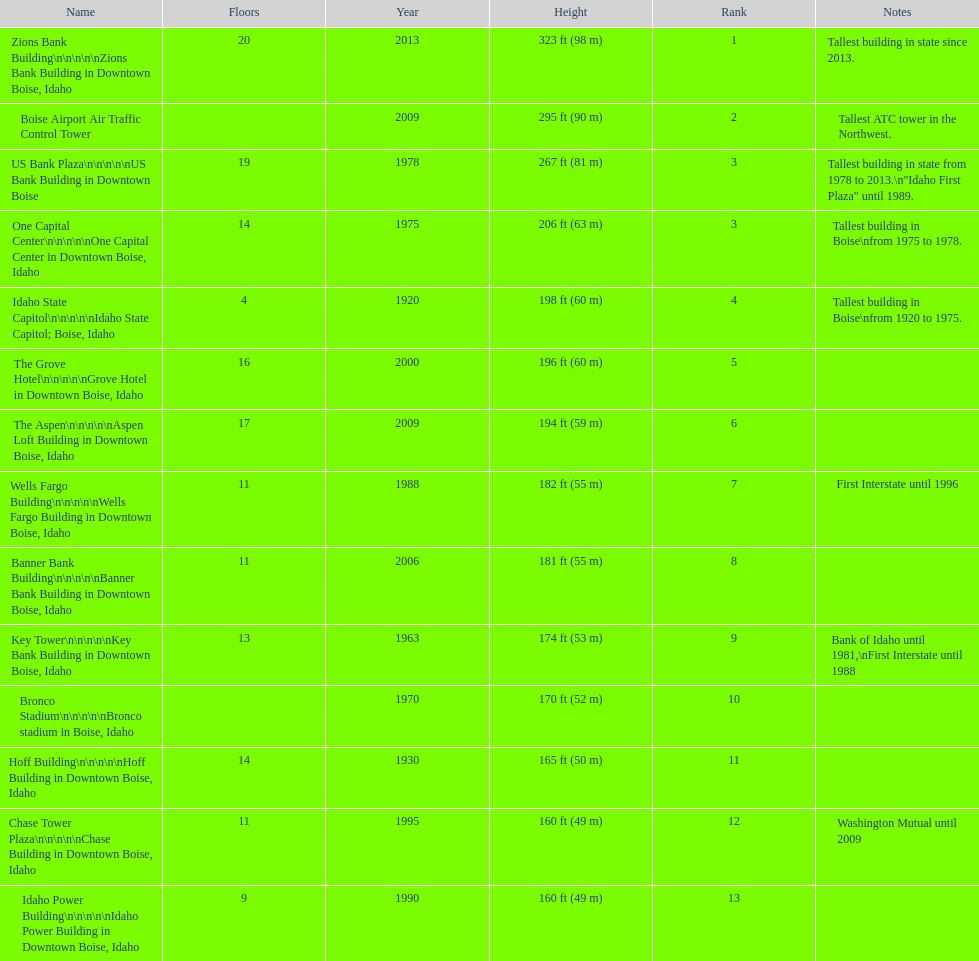Can you give me this table as a dict? {'header': ['Name', 'Floors', 'Year', 'Height', 'Rank', 'Notes'], 'rows': [['Zions Bank Building\\n\\n\\n\\n\\nZions Bank Building in Downtown Boise, Idaho', '20', '2013', '323\xa0ft (98\xa0m)', '1', 'Tallest building in state since 2013.'], ['Boise Airport Air Traffic Control Tower', '', '2009', '295\xa0ft (90\xa0m)', '2', 'Tallest ATC tower in the Northwest.'], ['US Bank Plaza\\n\\n\\n\\n\\nUS Bank Building in Downtown Boise', '19', '1978', '267\xa0ft (81\xa0m)', '3', 'Tallest building in state from 1978 to 2013.\\n"Idaho First Plaza" until 1989.'], ['One Capital Center\\n\\n\\n\\n\\nOne Capital Center in Downtown Boise, Idaho', '14', '1975', '206\xa0ft (63\xa0m)', '3', 'Tallest building in Boise\\nfrom 1975 to 1978.'], ['Idaho State Capitol\\n\\n\\n\\n\\nIdaho State Capitol; Boise, Idaho', '4', '1920', '198\xa0ft (60\xa0m)', '4', 'Tallest building in Boise\\nfrom 1920 to 1975.'], ['The Grove Hotel\\n\\n\\n\\n\\nGrove Hotel in Downtown Boise, Idaho', '16', '2000', '196\xa0ft (60\xa0m)', '5', ''], ['The Aspen\\n\\n\\n\\n\\nAspen Loft Building in Downtown Boise, Idaho', '17', '2009', '194\xa0ft (59\xa0m)', '6', ''], ['Wells Fargo Building\\n\\n\\n\\n\\nWells Fargo Building in Downtown Boise, Idaho', '11', '1988', '182\xa0ft (55\xa0m)', '7', 'First Interstate until 1996'], ['Banner Bank Building\\n\\n\\n\\n\\nBanner Bank Building in Downtown Boise, Idaho', '11', '2006', '181\xa0ft (55\xa0m)', '8', ''], ['Key Tower\\n\\n\\n\\n\\nKey Bank Building in Downtown Boise, Idaho', '13', '1963', '174\xa0ft (53\xa0m)', '9', 'Bank of Idaho until 1981,\\nFirst Interstate until 1988'], ['Bronco Stadium\\n\\n\\n\\n\\nBronco stadium in Boise, Idaho', '', '1970', '170\xa0ft (52\xa0m)', '10', ''], ['Hoff Building\\n\\n\\n\\n\\nHoff Building in Downtown Boise, Idaho', '14', '1930', '165\xa0ft (50\xa0m)', '11', ''], ['Chase Tower Plaza\\n\\n\\n\\n\\nChase Building in Downtown Boise, Idaho', '11', '1995', '160\xa0ft (49\xa0m)', '12', 'Washington Mutual until 2009'], ['Idaho Power Building\\n\\n\\n\\n\\nIdaho Power Building in Downtown Boise, Idaho', '9', '1990', '160\xa0ft (49\xa0m)', '13', '']]} What is the tallest building in bosie, idaho? Zions Bank Building Zions Bank Building in Downtown Boise, Idaho. 